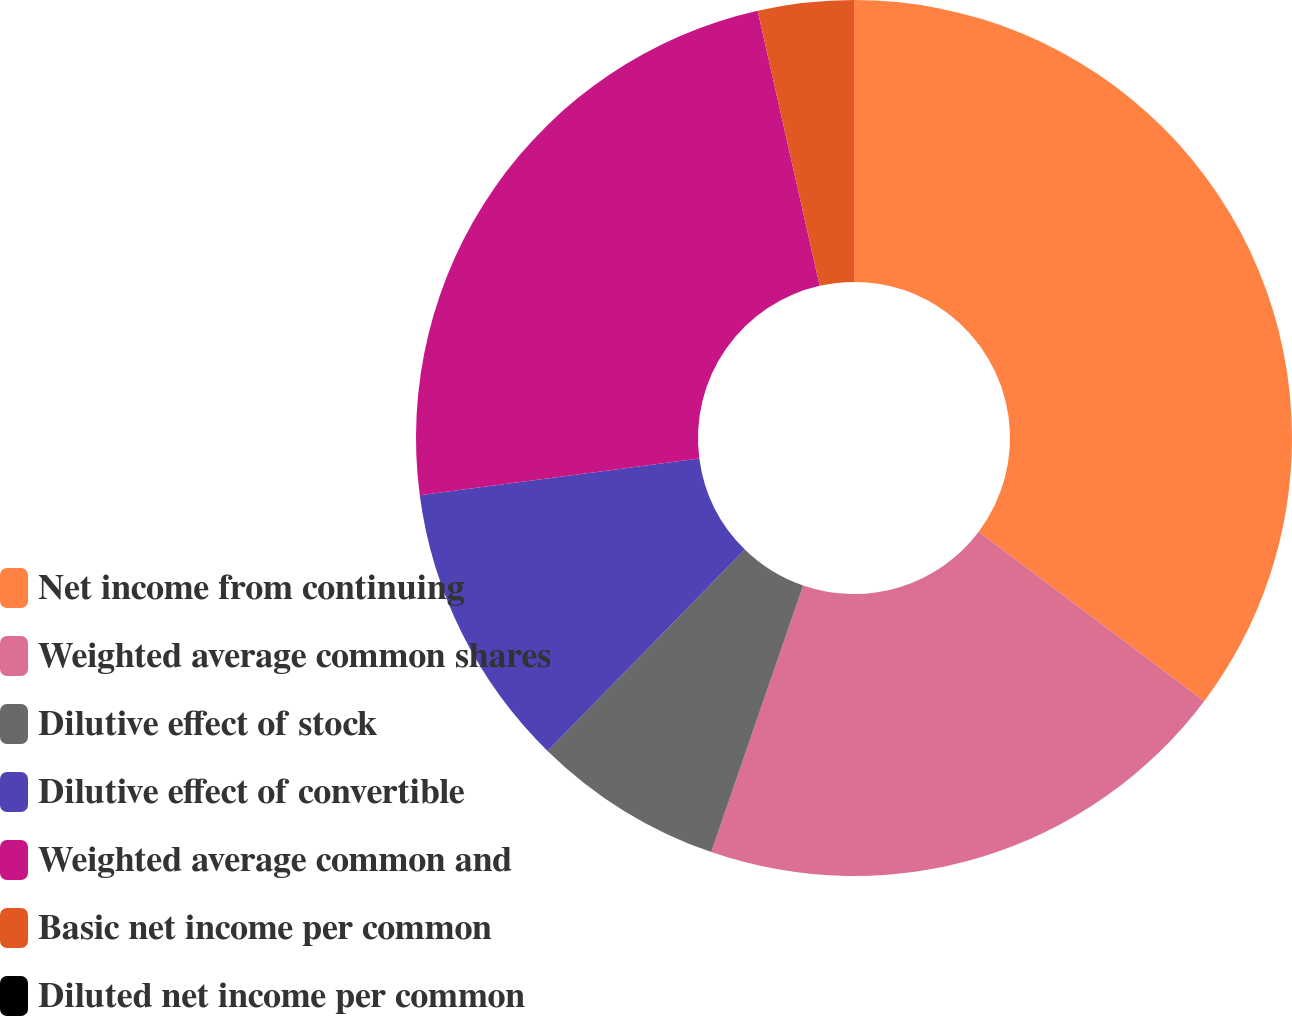Convert chart to OTSL. <chart><loc_0><loc_0><loc_500><loc_500><pie_chart><fcel>Net income from continuing<fcel>Weighted average common shares<fcel>Dilutive effect of stock<fcel>Dilutive effect of convertible<fcel>Weighted average common and<fcel>Basic net income per common<fcel>Diluted net income per common<nl><fcel>35.26%<fcel>20.03%<fcel>7.05%<fcel>10.58%<fcel>23.56%<fcel>3.53%<fcel>0.0%<nl></chart> 